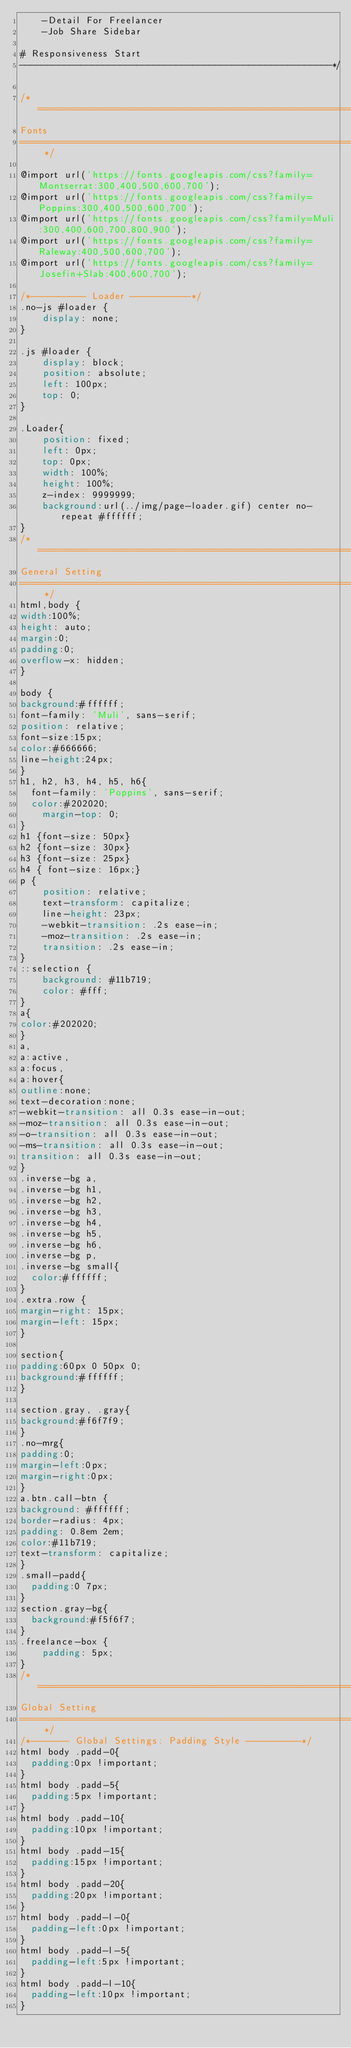<code> <loc_0><loc_0><loc_500><loc_500><_CSS_>		-Detail For Freelancer
		-Job Share Sidebar

# Responsiveness Start
--------------------------------------------------------*/

/* ==========================================================================
Fonts
========================================================================== */

@import url('https://fonts.googleapis.com/css?family=Montserrat:300,400,500,600,700');
@import url('https://fonts.googleapis.com/css?family=Poppins:300,400,500,600,700');
@import url('https://fonts.googleapis.com/css?family=Muli:300,400,600,700,800,900');
@import url('https://fonts.googleapis.com/css?family=Raleway:400,500,600,700');
@import url('https://fonts.googleapis.com/css?family=Josefin+Slab:400,600,700');

/*---------- Loader -----------*/
.no-js #loader {
    display: none;
}

.js #loader {
    display: block;
    position: absolute;
    left: 100px;
    top: 0;
}

.Loader{
    position: fixed;
    left: 0px;
    top: 0px;
    width: 100%;
    height: 100%;
    z-index: 9999999;
    background:url(../img/page-loader.gif) center no-repeat #ffffff;
}
/* ==========================================================================
General Setting
========================================================================== */
html,body {
width:100%;
height: auto;
margin:0;
padding:0;
overflow-x: hidden;
}

body {
background:#ffffff;
font-family: 'Muli', sans-serif;
position: relative;
font-size:15px;
color:#666666;
line-height:24px;
}
h1, h2, h3, h4, h5, h6{
	font-family: 'Poppins', sans-serif;
	color:#202020;
    margin-top: 0;
}
h1 {font-size: 50px}
h2 {font-size: 30px}
h3 {font-size: 25px}
h4 { font-size: 16px;}
p {
    position: relative;
    text-transform: capitalize;
    line-height: 23px;
    -webkit-transition: .2s ease-in;
    -moz-transition: .2s ease-in;
    transition: .2s ease-in;
}
::selection {
    background: #11b719;
    color: #fff;
}
a{
color:#202020;
}
a,
a:active,
a:focus,
a:hover{
outline:none;
text-decoration:none;
-webkit-transition: all 0.3s ease-in-out;
-moz-transition: all 0.3s ease-in-out;
-o-transition: all 0.3s ease-in-out;
-ms-transition: all 0.3s ease-in-out;
transition: all 0.3s ease-in-out;
}
.inverse-bg a,
.inverse-bg h1,
.inverse-bg h2,
.inverse-bg h3,
.inverse-bg h4,
.inverse-bg h5,
.inverse-bg h6,
.inverse-bg p,
.inverse-bg small{
	color:#ffffff;
}
.extra.row {
margin-right: 15px;
margin-left: 15px;
}

section{
padding:60px 0 50px 0;
background:#ffffff;
}

section.gray, .gray{
background:#f6f7f9;
}
.no-mrg{
padding:0;
margin-left:0px;
margin-right:0px;
}
a.btn.call-btn {
background: #ffffff;
border-radius: 4px;
padding: 0.8em 2em;
color:#11b719;
text-transform: capitalize;
}
.small-padd{
	padding:0 7px;
}
section.gray-bg{
	background:#f5f6f7;
}
.freelance-box {
    padding: 5px;
}
/* ==========================================================================
Global Setting
========================================================================== */
/*------- Global Settings: Padding Style ----------*/
html body .padd-0{
	padding:0px !important;
}
html body .padd-5{
	padding:5px !important;
}
html body .padd-10{
	padding:10px !important;
}
html body .padd-15{
	padding:15px !important;
}
html body .padd-20{
	padding:20px !important;
}
html body .padd-l-0{
	padding-left:0px !important;
}
html body .padd-l-5{
	padding-left:5px !important;
}
html body .padd-l-10{
	padding-left:10px !important;
}</code> 